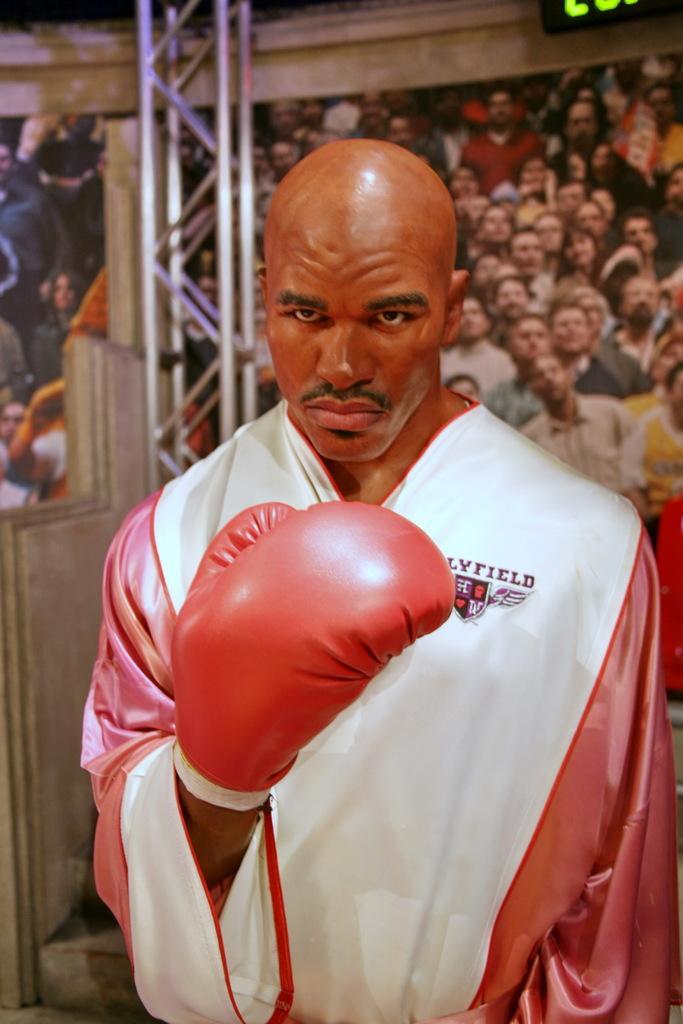Can you describe this image briefly? In this image we can see a man wearing the hand glove. In the background we can see many people. We can also see the rods. There is a display screen in the top left corner. 